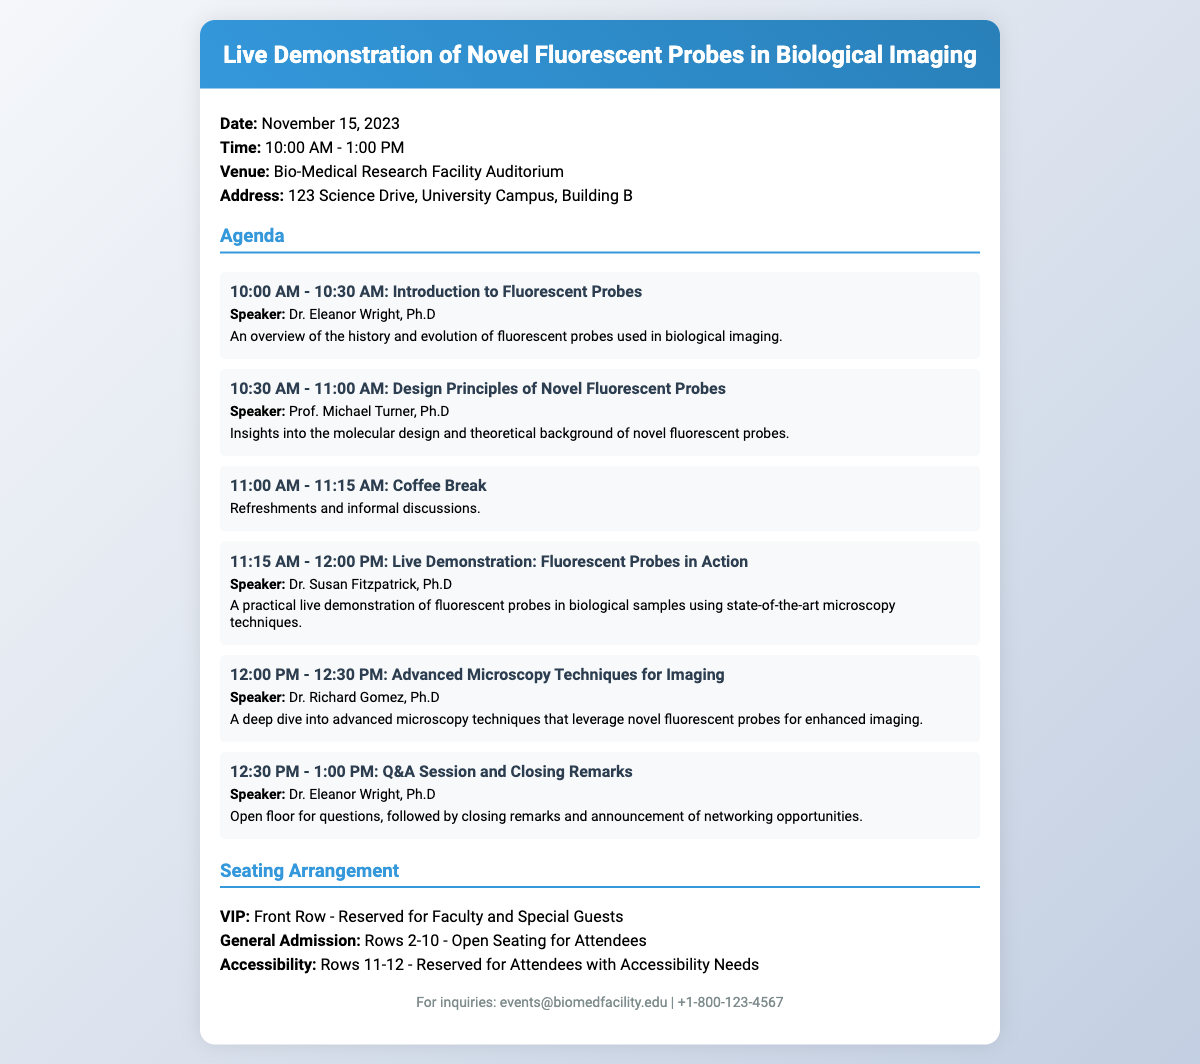What is the date of the event? The date is explicitly stated in the document as November 15, 2023.
Answer: November 15, 2023 What time does the event start? The start time is mentioned in the event details section as 10:00 AM.
Answer: 10:00 AM Who is the speaker for the live demonstration section? The speaker for the live demonstration is listed in the agenda as Dr. Susan Fitzpatrick, Ph.D.
Answer: Dr. Susan Fitzpatrick, Ph.D How many speakers are there in total? By counting the speaker entries in the agenda, there are six speakers mentioned throughout.
Answer: 6 What type of seating arrangement is available for faculty and special guests? The document specifies a "Front Row" seating arrangement reserved for this group.
Answer: Front Row What is the duration of the Q&A session? The duration of the Q&A session is indicated in the agenda as 30 minutes.
Answer: 30 minutes Which rows are reserved for attendees with accessibility needs? The document states that Rows 11-12 are reserved for this purpose.
Answer: Rows 11-12 What is the venue of the demonstration? The venue is specified as the Bio-Medical Research Facility Auditorium.
Answer: Bio-Medical Research Facility Auditorium What kind of event is described in the document? The document describes a "Live Demonstration of Novel Fluorescent Probes in Biological Imaging."
Answer: Live Demonstration of Novel Fluorescent Probes in Biological Imaging 